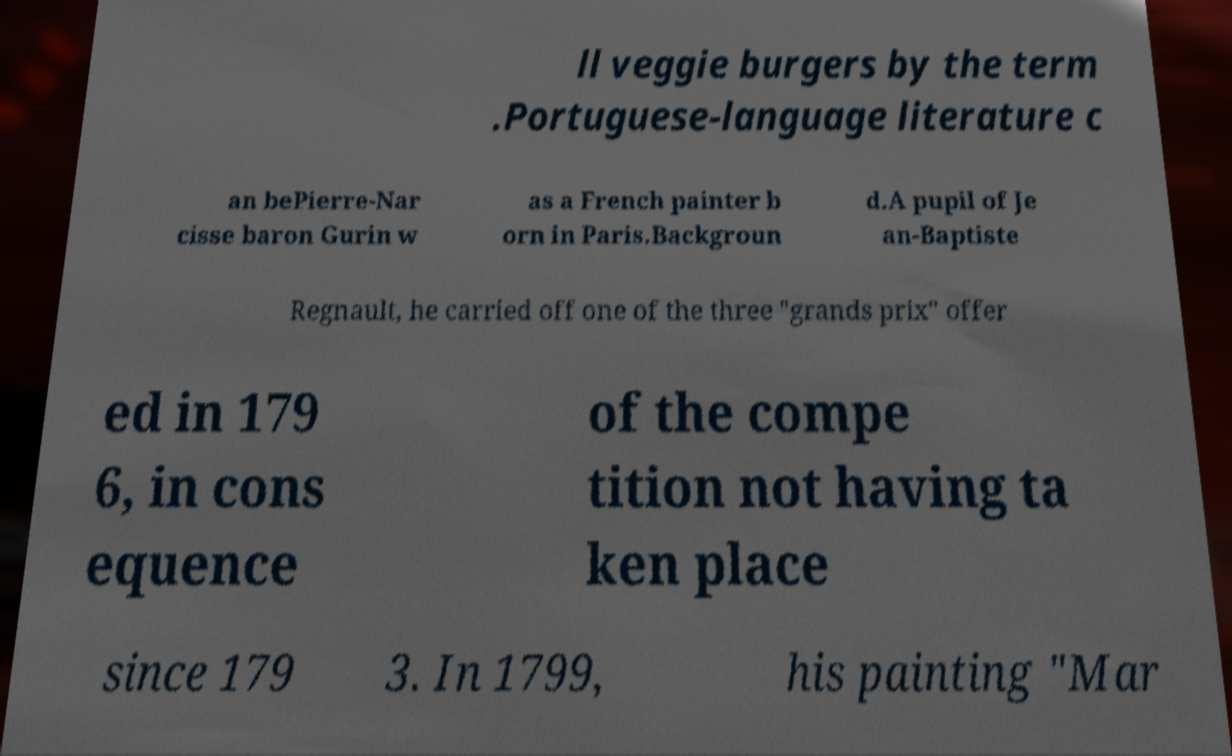Can you read and provide the text displayed in the image?This photo seems to have some interesting text. Can you extract and type it out for me? ll veggie burgers by the term .Portuguese-language literature c an bePierre-Nar cisse baron Gurin w as a French painter b orn in Paris.Backgroun d.A pupil of Je an-Baptiste Regnault, he carried off one of the three "grands prix" offer ed in 179 6, in cons equence of the compe tition not having ta ken place since 179 3. In 1799, his painting "Mar 